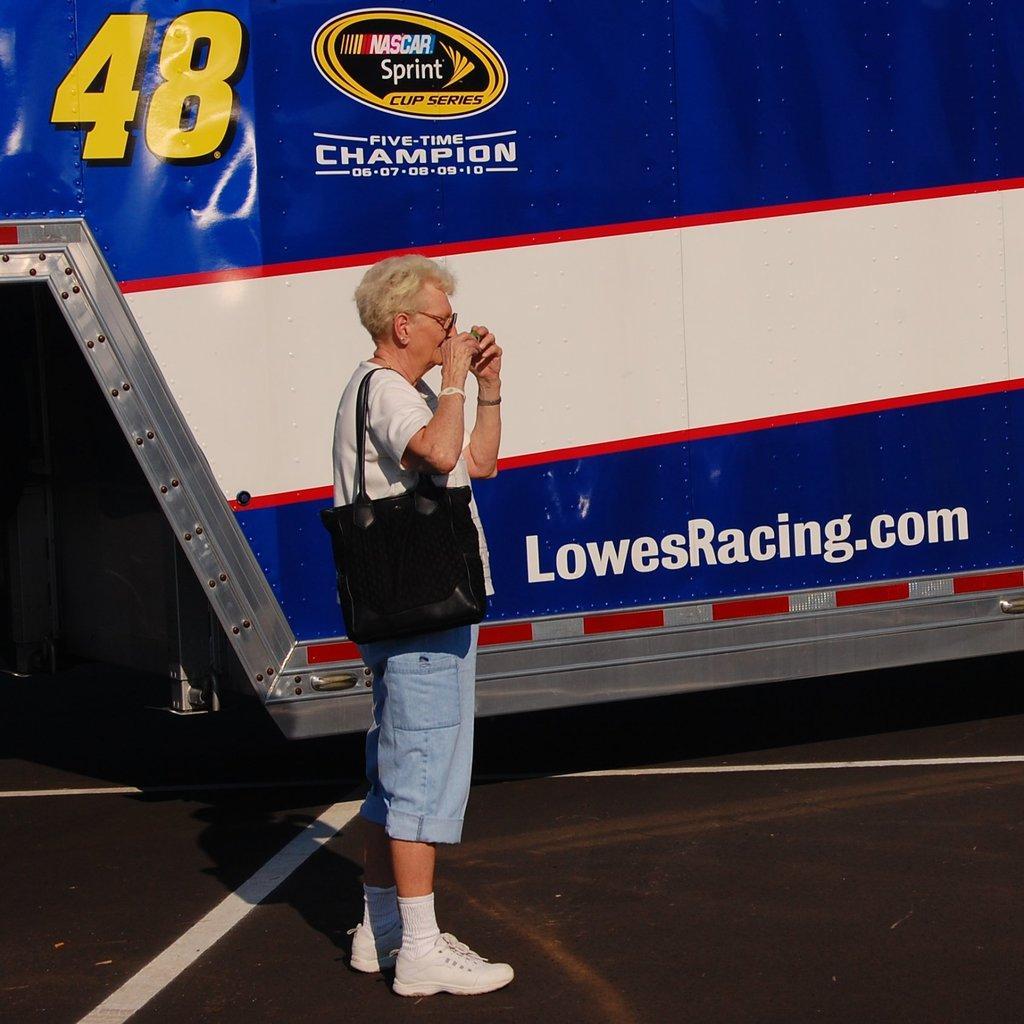Please provide a concise description of this image. In this image in the front there is a woman standing and holding a bag which is black in colour. In the background there is board with some text written on it and there are numbers written on the board which are blue and white in colour. 